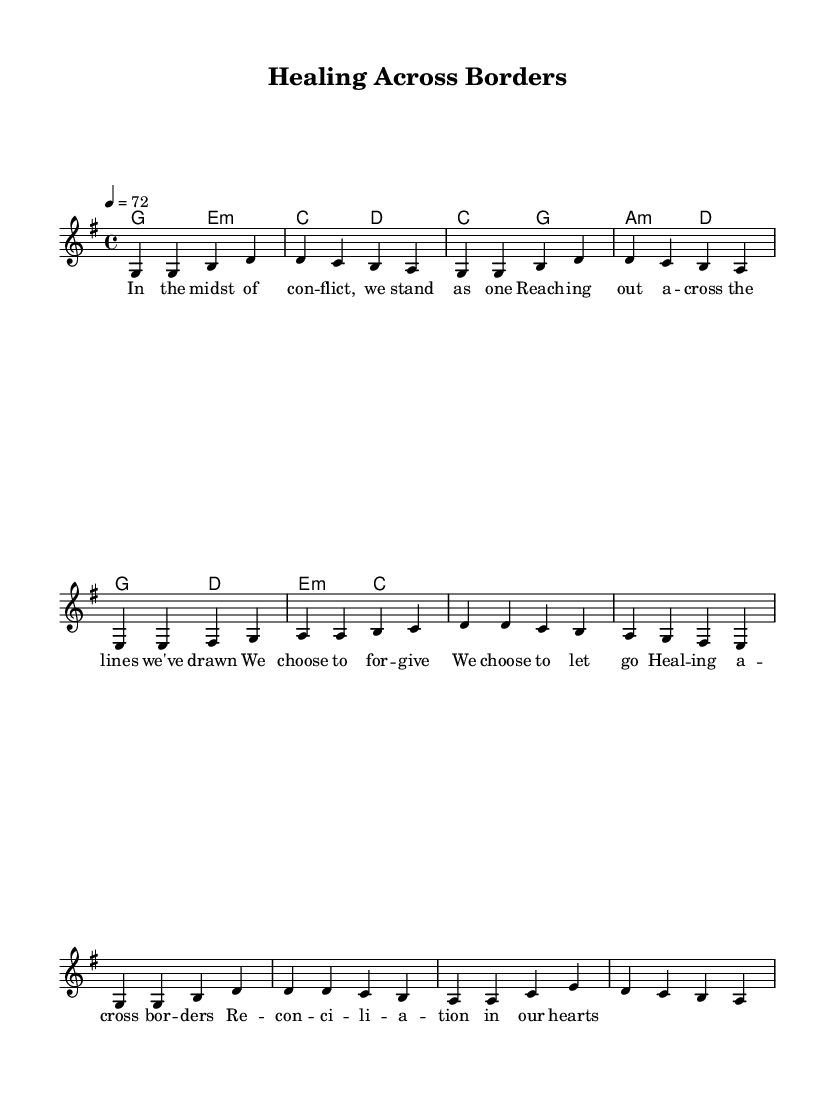What is the key signature of this music? The key signature is indicated at the beginning of the staff. In this case, the presence of one sharp indicates that the key is G major.
Answer: G major What is the time signature of this music? The time signature is also shown at the beginning of the staff. It is indicated as 4/4, meaning there are four beats per measure and the quarter note gets one beat.
Answer: 4/4 What is the tempo marking for this piece? The tempo is specified with a number and a text indication. Here, it states "4 = 72," which means there are 72 beats per minute, and it corresponds to a quarter note.
Answer: 72 How many lines are in the staff for the melody? A standard staff consists of five lines. The melody section also shows five lines where the notes are placed. Thus, the staff has five lines.
Answer: Five What is the main theme addressed in the lyrics of this piece? By examining the lyrics provided, the main theme reflects forgiveness and healing, particularly focusing on conflict resolution and reconciliation. Hence, it addresses the theme of peace and unity.
Answer: Peace and reconciliation Which chord is used at the beginning of the verse? The chord at the start of the verse is indicated in the harmonies section, and the first chord is G major. This means the music starts with the G major chord.
Answer: G major What emotional tone do the lyrics convey? The lyrics express themes of healing and togetherness amidst conflict. The word choices such as "forgive" and "reconciliation" suggest a positive and hopeful emotional tone focused on unity.
Answer: Hopeful 